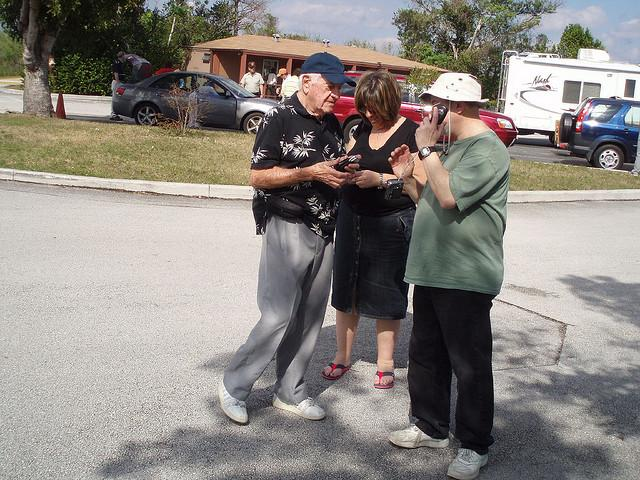Which person is the oldest? man 